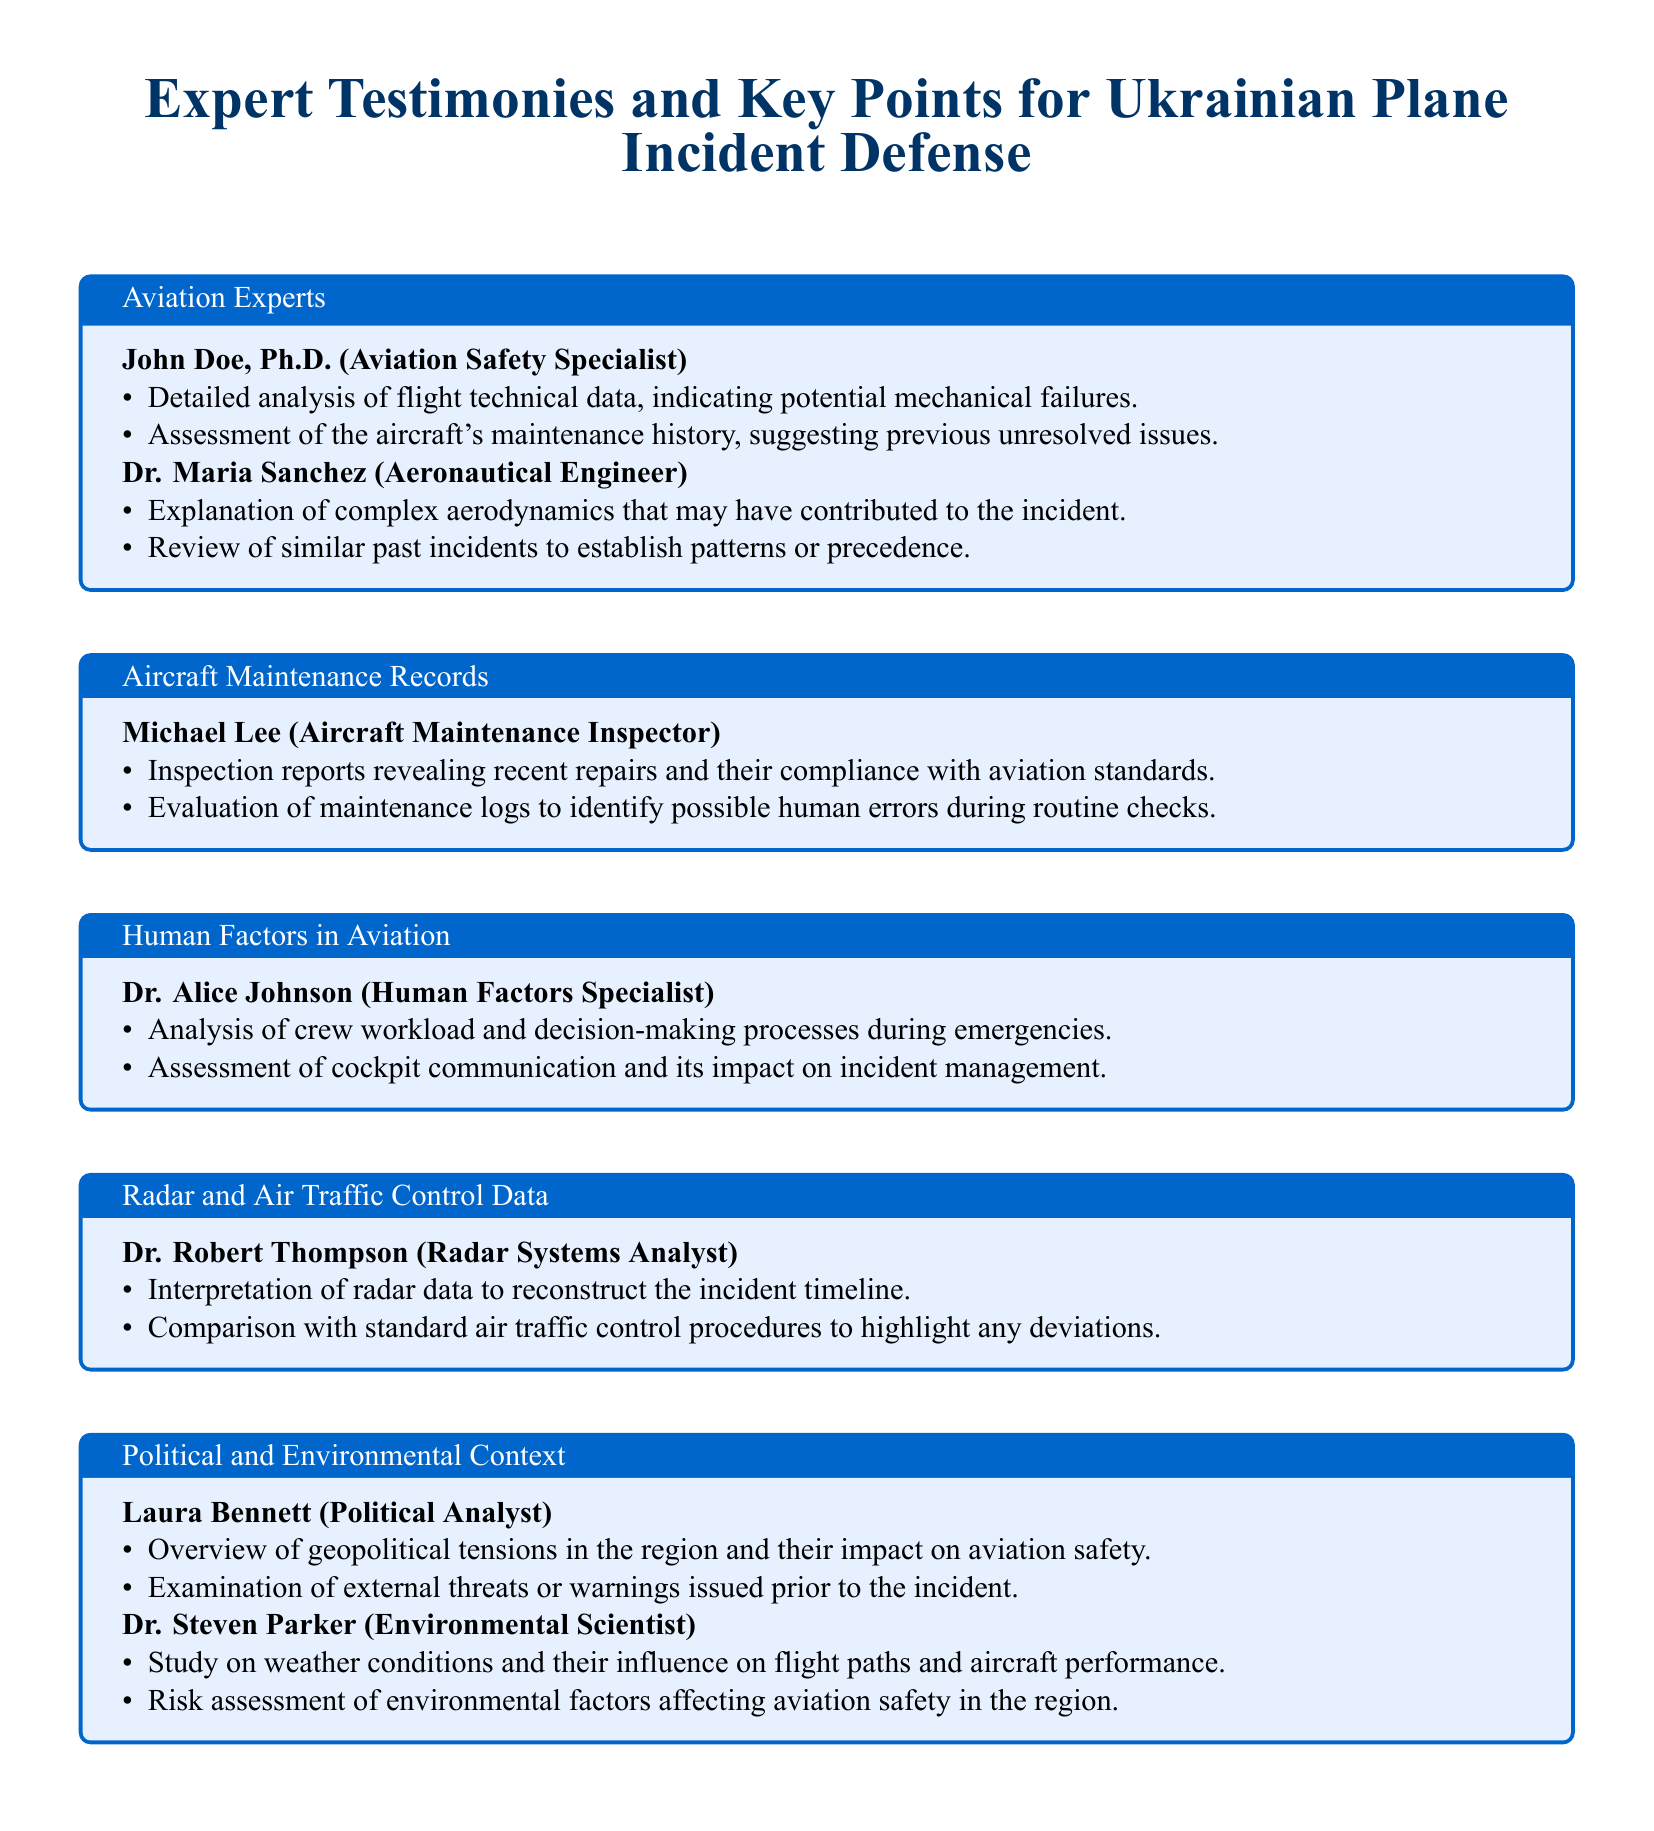What is John Doe's title? John Doe is identified as an Aviation Safety Specialist in the document.
Answer: Aviation Safety Specialist What did Dr. Maria Sanchez explain? Dr. Maria Sanchez provided an explanation of complex aerodynamics that may have contributed to the incident.
Answer: Complex aerodynamics What is Michael Lee's area of expertise? Michael Lee is recognized as an Aircraft Maintenance Inspector.
Answer: Aircraft Maintenance Inspector What type of analysis did Dr. Alice Johnson perform? Dr. Alice Johnson conducted an analysis of crew workload and decision-making processes during emergencies.
Answer: Crew workload and decision-making What did Dr. Robert Thompson interpret? Dr. Robert Thompson interpreted radar data to reconstruct the incident timeline.
Answer: Radar data What external factor did Laura Bennett examine? Laura Bennett examined external threats or warnings issued prior to the incident.
Answer: External threats or warnings What was studied by Dr. Steven Parker? Dr. Steven Parker studied weather conditions and their influence on flight paths and aircraft performance.
Answer: Weather conditions How many experts are mentioned in the document? The document mentions five experts in total.
Answer: Five experts What does the tcolorbox for Aviation Experts contain? The tcolorbox for Aviation Experts contains information about John Doe and Dr. Maria Sanchez, their titles, and key points of their testimonies.
Answer: Information about John Doe and Dr. Maria Sanchez 